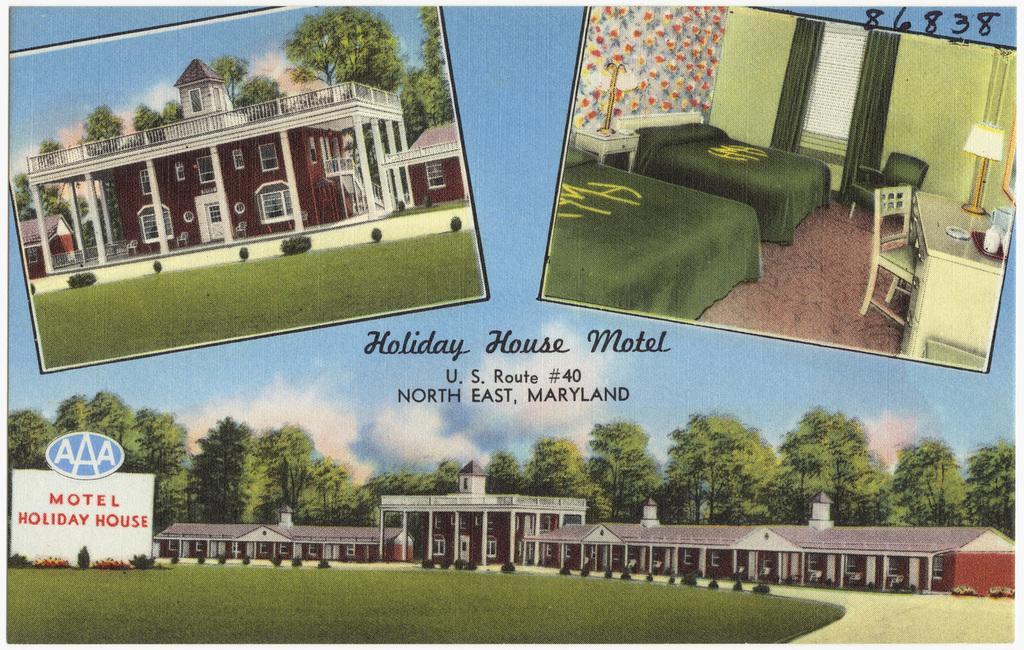Could you give a brief overview of what you see in this image? In the image in the center,we can see one poster. On the poster,we can see buildings,trees,plants,grass,beds,tables,chairs,lamps,curtains etc. In the background we can see the sky,clouds and trees. And we can see something written on the poster. 